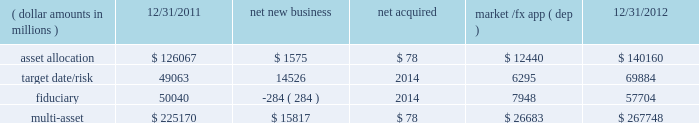Although many clients use both active and passive strategies , the application of these strategies differs greatly .
For example , clients may use index products to gain exposure to a market or asset class pending reallocation to an active manager .
This has the effect of increasing turnover of index aum .
In addition , institutional non-etp index assignments tend to be very large ( multi- billion dollars ) and typically reflect low fee rates .
This has the potential to exaggerate the significance of net flows in institutional index products on blackrock 2019s revenues and earnings .
Equity year-end 2012 equity aum of $ 1.845 trillion increased by $ 285.4 billion , or 18% ( 18 % ) , from the end of 2011 , largely due to flows into regional , country-specific and global mandates and the effect of higher market valuations .
Equity aum growth included $ 54.0 billion in net new business and $ 3.6 billion in new assets related to the acquisition of claymore .
Net new business of $ 54.0 billion was driven by net inflows of $ 53.0 billion and $ 19.1 billion into ishares and non-etp index accounts , respectively .
Passive inflows were offset by active net outflows of $ 18.1 billion , with net outflows of $ 10.0 billion and $ 8.1 billion from fundamental and scientific active equity products , respectively .
Passive strategies represented 84% ( 84 % ) of equity aum with the remaining 16% ( 16 % ) in active mandates .
Institutional investors represented 62% ( 62 % ) of equity aum , while ishares , and retail and hnw represented 29% ( 29 % ) and 9% ( 9 % ) , respectively .
At year-end 2012 , 63% ( 63 % ) of equity aum was managed for clients in the americas ( defined as the united states , caribbean , canada , latin america and iberia ) compared with 28% ( 28 % ) and 9% ( 9 % ) managed for clients in emea and asia-pacific , respectively .
Blackrock 2019s effective fee rates fluctuate due to changes in aum mix .
Approximately half of blackrock 2019s equity aum is tied to international markets , including emerging markets , which tend to have higher fee rates than similar u.s .
Equity strategies .
Accordingly , fluctuations in international equity markets , which do not consistently move in tandem with u.s .
Markets , may have a greater impact on blackrock 2019s effective equity fee rates and revenues .
Fixed income fixed income aum ended 2012 at $ 1.259 trillion , rising $ 11.6 billion , or 1% ( 1 % ) , relative to december 31 , 2011 .
Growth in aum reflected $ 43.3 billion in net new business , excluding the two large previously mentioned low-fee outflows , $ 75.4 billion in market and foreign exchange gains and $ 3.0 billion in new assets related to claymore .
Net new business was led by flows into domestic specialty and global bond mandates , with net inflows of $ 28.8 billion , $ 13.6 billion and $ 3.1 billion into ishares , non-etp index and model-based products , respectively , partially offset by net outflows of $ 2.2 billion from fundamental strategies .
Fixed income aum was split between passive and active strategies with 48% ( 48 % ) and 52% ( 52 % ) , respectively .
Institutional investors represented 74% ( 74 % ) of fixed income aum while ishares and retail and hnw represented 15% ( 15 % ) and 11% ( 11 % ) , respectively .
At year-end 2012 , 59% ( 59 % ) of fixed income aum was managed for clients in the americas compared with 33% ( 33 % ) and 8% ( 8 % ) managed for clients in emea and asia- pacific , respectively .
Multi-asset class component changes in multi-asset class aum ( dollar amounts in millions ) 12/31/2011 net new business acquired market /fx app ( dep ) 12/31/2012 .
Multi-asset class aum totaled $ 267.7 billion at year-end 2012 , up 19% ( 19 % ) , or $ 42.6 billion , reflecting $ 15.8 billion in net new business and $ 26.7 billion in portfolio valuation gains .
Blackrock 2019s multi-asset class team manages a variety of bespoke mandates for a diversified client base that leverages our broad investment expertise in global equities , currencies , bonds and commodities , and our extensive risk management capabilities .
Investment solutions might include a combination of long-only portfolios and alternative investments as well as tactical asset allocation overlays .
At december 31 , 2012 , institutional investors represented 66% ( 66 % ) of multi-asset class aum , while retail and hnw accounted for the remaining aum .
Additionally , 58% ( 58 % ) of multi-asset class aum is managed for clients based in the americas with 37% ( 37 % ) and 5% ( 5 % ) managed for clients in emea and asia-pacific , respectively .
Flows reflected ongoing institutional demand for our advice in an increasingly .
What portion of the total multi-assets is related to asset allocation as of december 31 , 2011? 
Computations: (126067 / 225170)
Answer: 0.55987. 